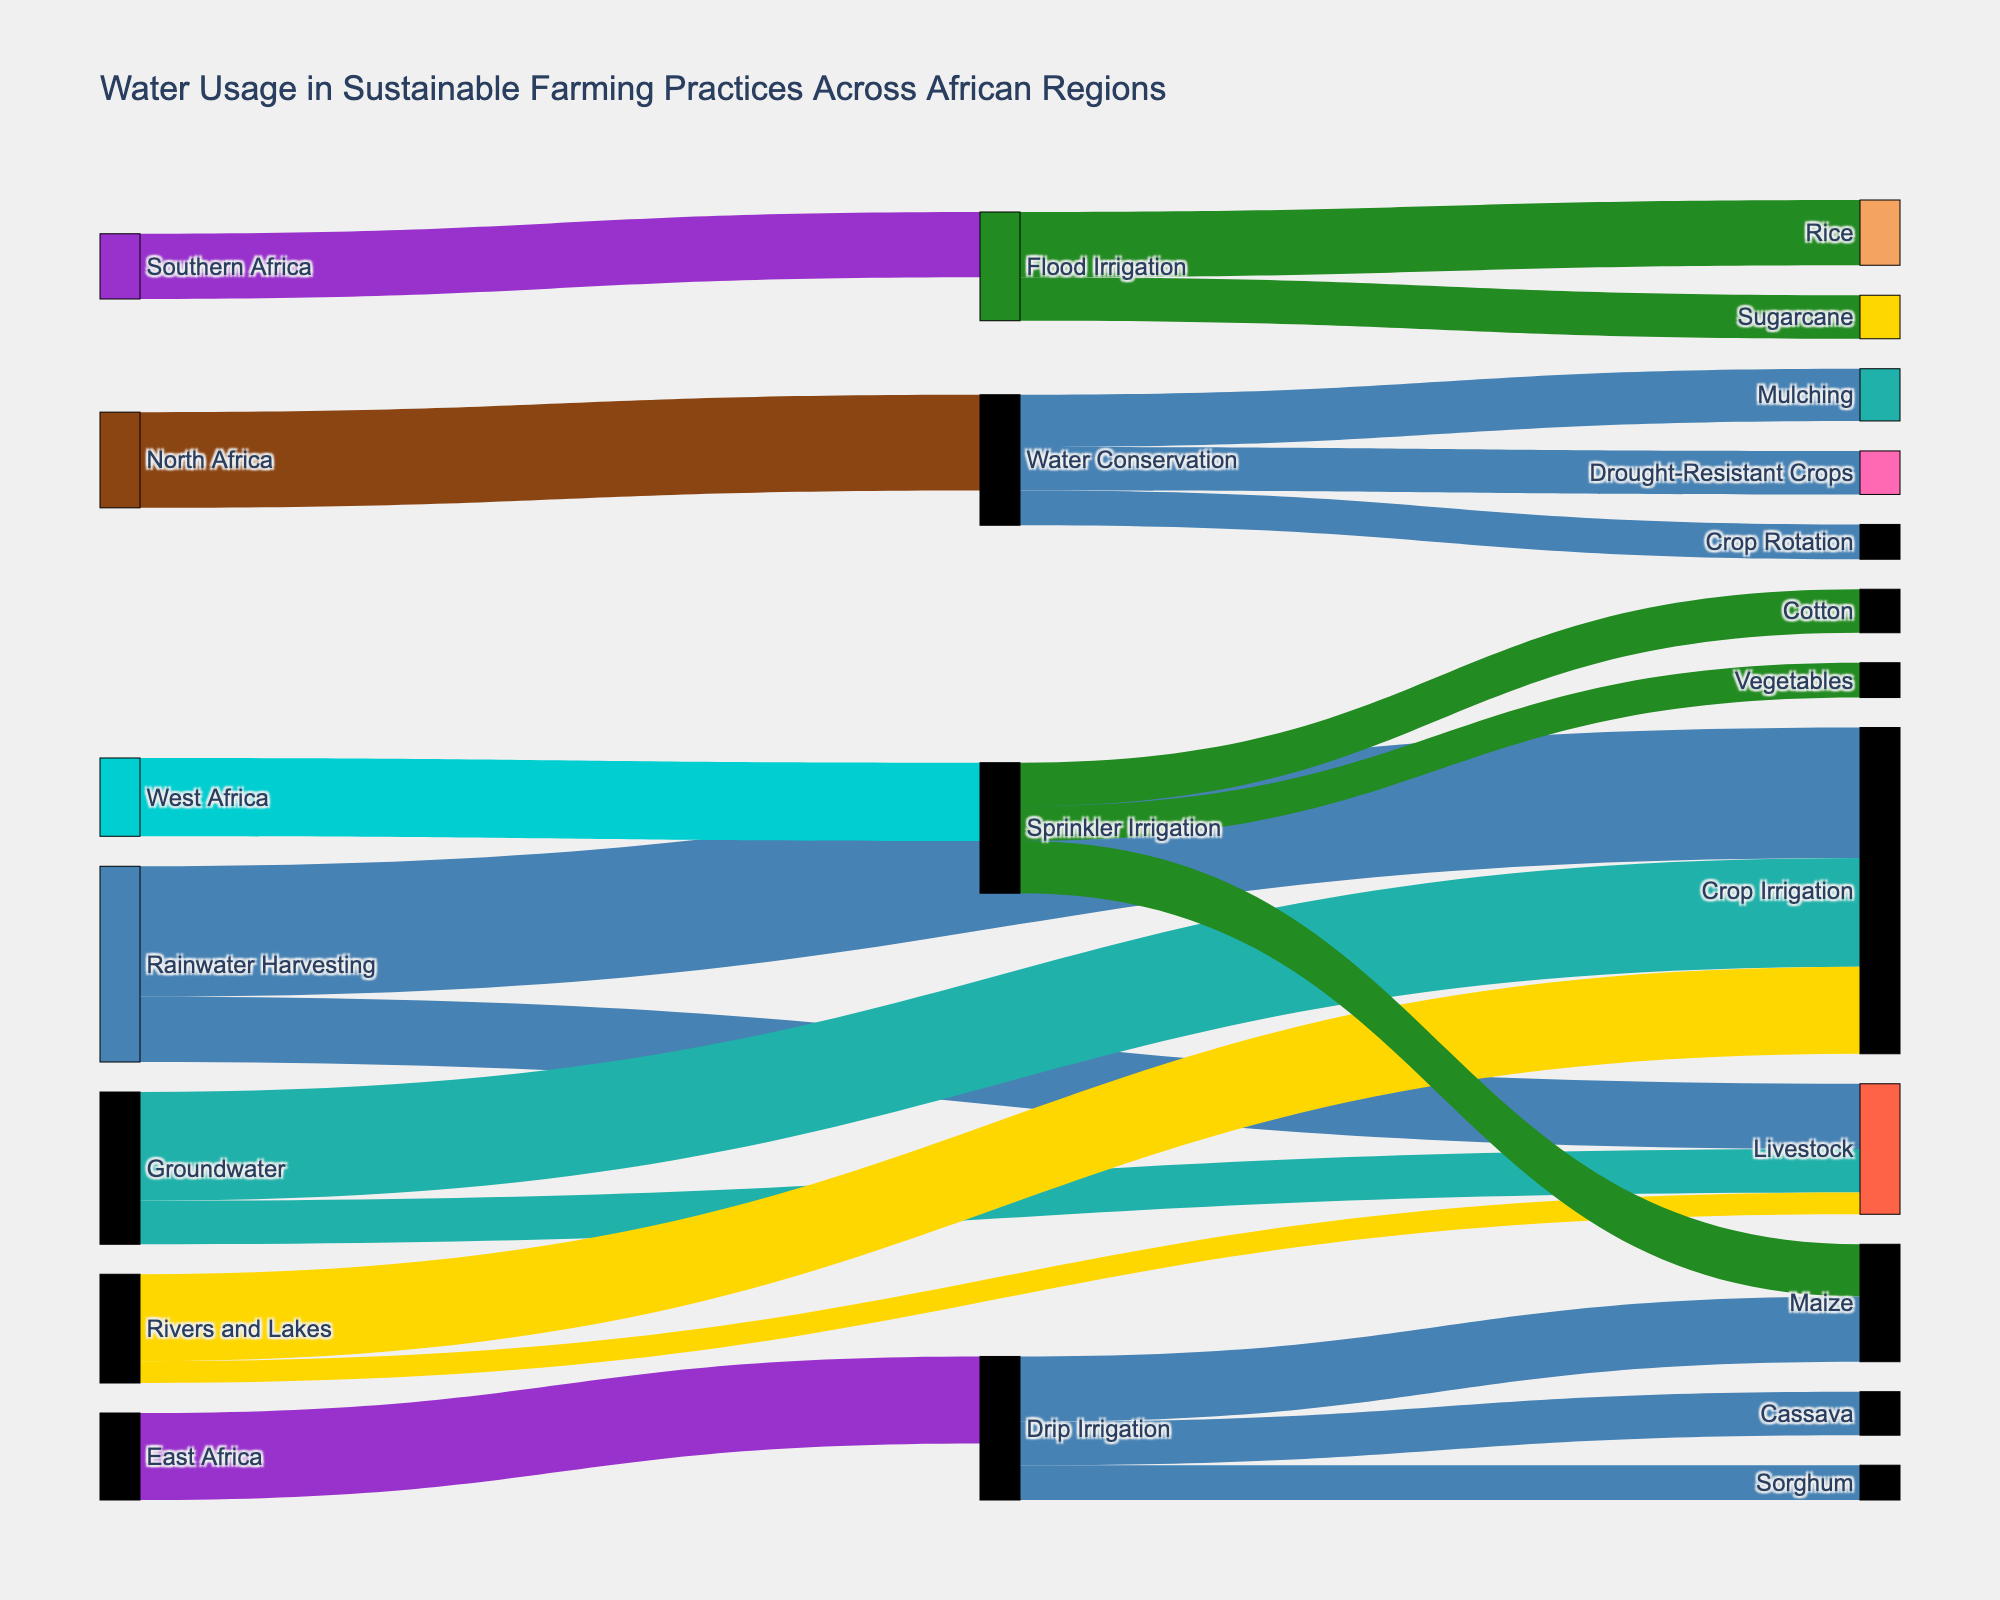What is the title of the figure? The title is usually found at the top of the figure. In this case, it explains the overall theme of the visual representation.
Answer: "Water Usage in Sustainable Farming Practices Across African Regions" How much rainwater is used for crop irrigation? Locate the flow from 'Rainwater Harvesting' to 'Crop Irrigation' in the diagram, and find the associated value.
Answer: 30 Which irrigation method is used the most in West Africa? Look at the region label 'West Africa' and trace the corresponding irrigation method mentioned with the highest value.
Answer: Sprinkler Irrigation What is the total amount of water used for livestock from all sources? Sum the values associated with livestock from `Rainwater Harvesting`, `Groundwater`, and `Rivers and Lakes`.
Answer: 30 (15 + 10 + 5) Compare the usage of water for Maize in Drip Irrigation and Sprinkler Irrigation. Which one is higher? Identify the values for Maize under both `Drip Irrigation` and `Sprinkler Irrigation`, then compare them.
Answer: Drip Irrigation for Maize is higher (15 vs 12) What is the difference in water usage between crop irrigation and livestock for groundwater? Find the values for `Crop Irrigation` and `Livestock` under `Groundwater`, then compute the difference.
Answer: 15 (25 - 10) What is the total water usage for maize considering all irrigation methods? Summing the values for Maize under `Drip Irrigation` and `Sprinkler Irrigation` in the figure.
Answer: 27 (15 + 12) Which region uses the most water for water conservation practices? Track which region is associated with 'Water Conservation' and pick the one with the highest value.
Answer: North Africa What are the three practices under Water Conservation and their associated water usage values? Identify the target nodes coming from `Water Conservation` and read their values.
Answer: Mulching (12), Crop Rotation (8), Drought-Resistant Crops (10) What is the combined water usage for Cassava and Sorghum in drip irrigation? Sum the values of `Cassava` and `Sorghum` under `Drip Irrigation`.
Answer: 18 (10 + 8) 